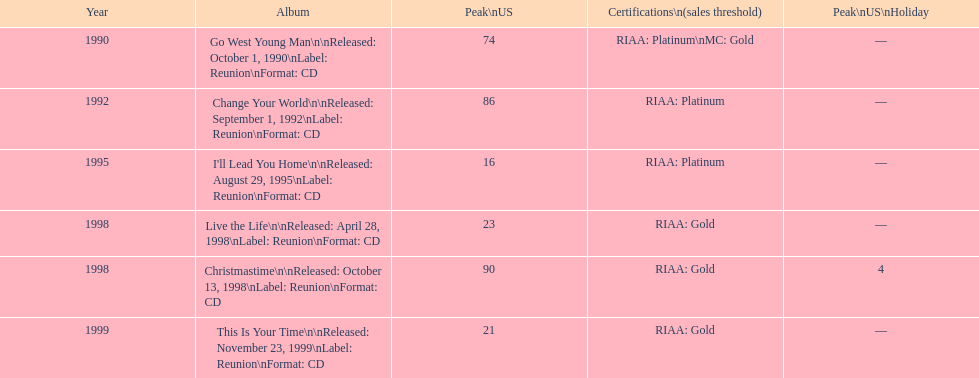What michael w smith album was released before his christmastime album? Live the Life. 